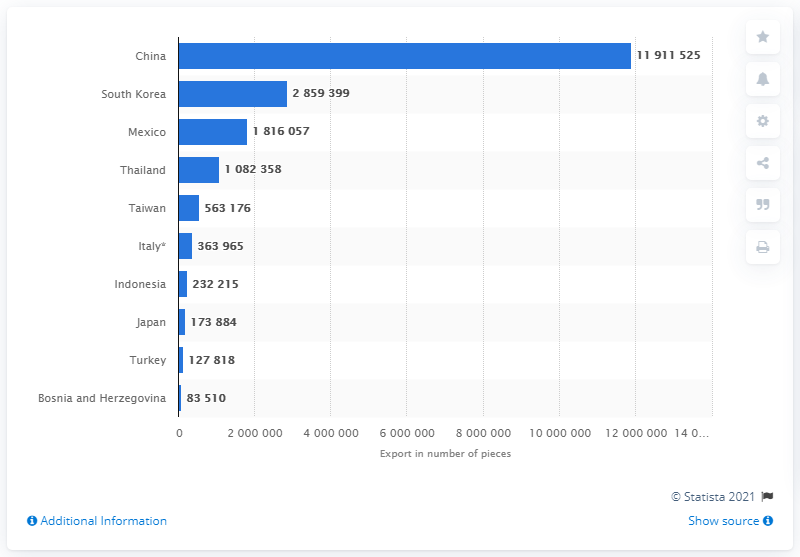List a handful of essential elements in this visual. In 2017, the United States exported a total of 285,939.9 kilograms of cattle hide to South Korea. The country that came in second in the United States in terms of exporting the most cattle hides in 2017 was South Korea. 